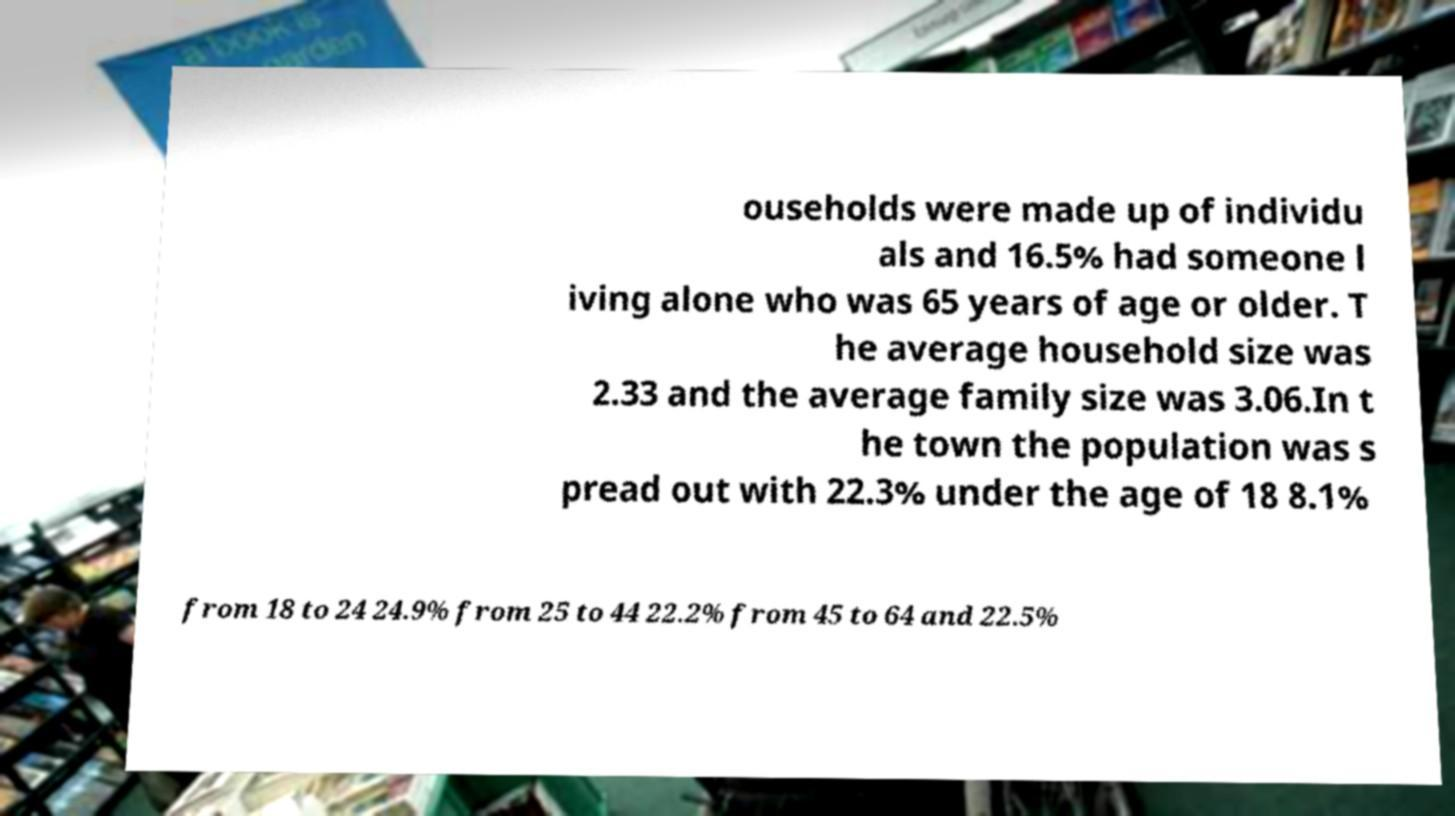Could you extract and type out the text from this image? ouseholds were made up of individu als and 16.5% had someone l iving alone who was 65 years of age or older. T he average household size was 2.33 and the average family size was 3.06.In t he town the population was s pread out with 22.3% under the age of 18 8.1% from 18 to 24 24.9% from 25 to 44 22.2% from 45 to 64 and 22.5% 